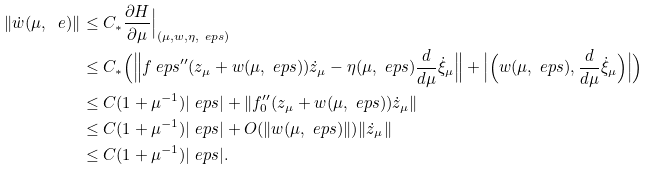Convert formula to latex. <formula><loc_0><loc_0><loc_500><loc_500>\| \dot { w } ( \mu , \ e ) \| & \leq C _ { * } \frac { \partial H } { \partial \mu } \Big | _ { ( \mu , w , \eta , \ e p s ) } \\ & \leq C _ { * } \Big ( \Big \| f _ { \ } e p s ^ { \prime \prime } ( z _ { \mu } + w ( \mu , \ e p s ) ) \dot { z } _ { \mu } - \eta ( \mu , \ e p s ) \frac { d } { d \mu } \dot { \xi } _ { \mu } \Big \| + \Big | \Big ( w ( \mu , \ e p s ) , \frac { d } { d \mu } \dot { \xi } _ { \mu } \Big ) \Big | \Big ) \\ & \leq C ( 1 + \mu ^ { - 1 } ) | \ e p s | + \| f _ { 0 } ^ { \prime \prime } ( z _ { \mu } + w ( \mu , \ e p s ) ) \dot { z } _ { \mu } \| \\ & \leq C ( 1 + \mu ^ { - 1 } ) | \ e p s | + O ( \| w ( \mu , \ e p s ) \| ) \| \dot { z } _ { \mu } \| \\ & \leq C ( 1 + \mu ^ { - 1 } ) | \ e p s | .</formula> 